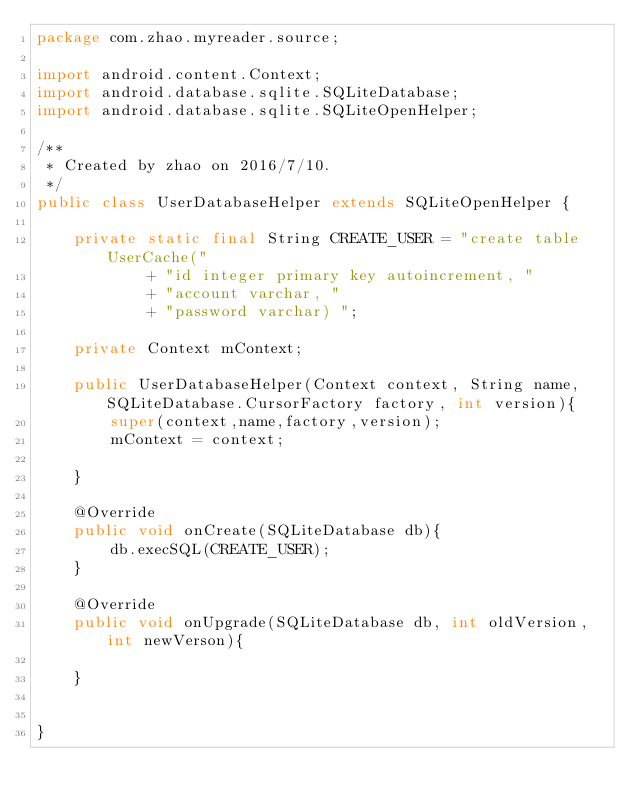<code> <loc_0><loc_0><loc_500><loc_500><_Java_>package com.zhao.myreader.source;

import android.content.Context;
import android.database.sqlite.SQLiteDatabase;
import android.database.sqlite.SQLiteOpenHelper;

/**
 * Created by zhao on 2016/7/10.
 */
public class UserDatabaseHelper extends SQLiteOpenHelper {

    private static final String CREATE_USER = "create table UserCache("
            + "id integer primary key autoincrement, "
            + "account varchar, "
            + "password varchar) ";

    private Context mContext;

    public UserDatabaseHelper(Context context, String name, SQLiteDatabase.CursorFactory factory, int version){
        super(context,name,factory,version);
        mContext = context;

    }

    @Override
    public void onCreate(SQLiteDatabase db){
        db.execSQL(CREATE_USER);
    }

    @Override
    public void onUpgrade(SQLiteDatabase db, int oldVersion, int newVerson){

    }


}
</code> 